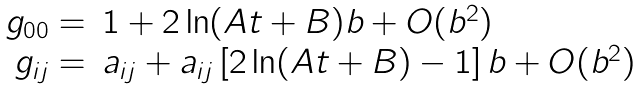Convert formula to latex. <formula><loc_0><loc_0><loc_500><loc_500>\begin{array} { r l } g _ { 0 0 } = & 1 + 2 \ln ( A t + B ) b + O ( b ^ { 2 } ) \\ g _ { i j } = & a _ { i j } + a _ { i j } \left [ 2 \ln ( A t + B ) - 1 \right ] b + O ( b ^ { 2 } ) \end{array}</formula> 